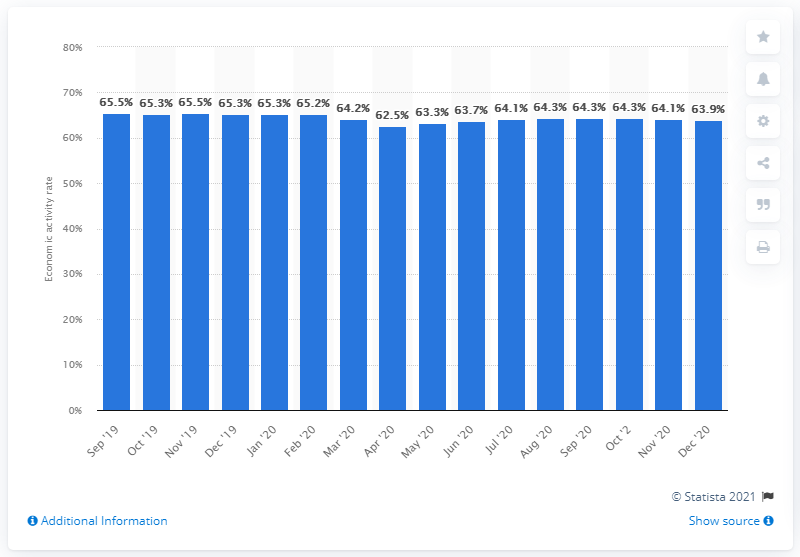Indicate a few pertinent items in this graphic. As of December 2020, Italy's economic activity rate was 63.9%. 